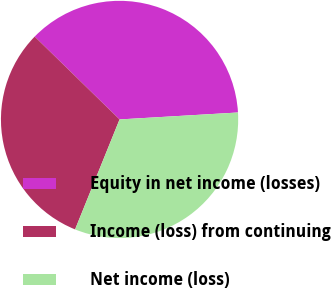Convert chart to OTSL. <chart><loc_0><loc_0><loc_500><loc_500><pie_chart><fcel>Equity in net income (losses)<fcel>Income (loss) from continuing<fcel>Net income (loss)<nl><fcel>36.76%<fcel>31.19%<fcel>32.05%<nl></chart> 